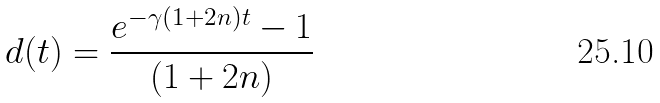<formula> <loc_0><loc_0><loc_500><loc_500>d ( t ) = \frac { e ^ { - \gamma ( 1 + 2 n ) t } - 1 } { ( 1 + 2 n ) }</formula> 